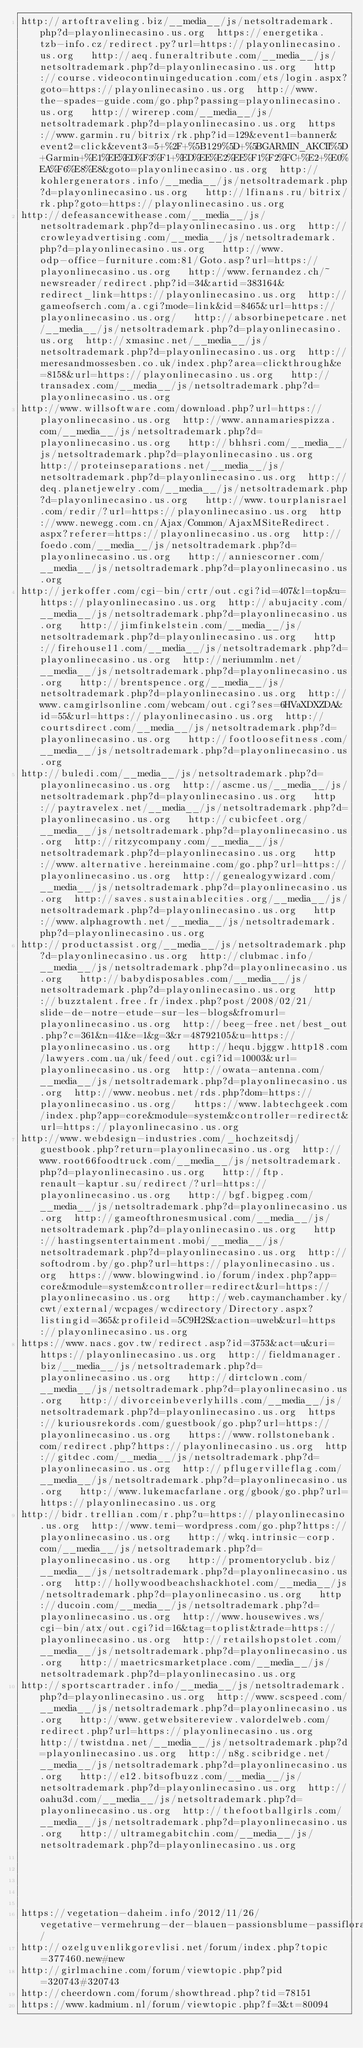<code> <loc_0><loc_0><loc_500><loc_500><_Lisp_>http://artoftraveling.biz/__media__/js/netsoltrademark.php?d=playonlinecasino.us.org  https://energetika.tzb-info.cz/redirect.py?url=https://playonlinecasino.us.org   http://aeq.funeraltribute.com/__media__/js/netsoltrademark.php?d=playonlinecasino.us.org   http://course.videocontinuingeducation.com/ets/login.aspx?goto=https://playonlinecasino.us.org  http://www.the-spades-guide.com/go.php?passing=playonlinecasino.us.org   http://wirerep.com/__media__/js/netsoltrademark.php?d=playonlinecasino.us.org  https://www.garmin.ru/bitrix/rk.php?id=129&event1=banner&event2=click&event3=5+%2F+%5B129%5D+%5BGARMIN_AKCII%5D+Garmin+%E1%EE%ED%F3%F1+%ED%EE%E2%EE%F1%F2%FC+%E2+%E0%EA%F6%E8%E8&goto=playonlinecasino.us.org  http://kohlergenerators.info/__media__/js/netsoltrademark.php?d=playonlinecasino.us.org   http://lfinans.ru/bitrix/rk.php?goto=https://playonlinecasino.us.org 
http://defeasancewithease.com/__media__/js/netsoltrademark.php?d=playonlinecasino.us.org  http://crowleyadvertising.com/__media__/js/netsoltrademark.php?d=playonlinecasino.us.org   http://www.odp-office-furniture.com:81/Goto.asp?url=https://playonlinecasino.us.org   http://www.fernandez.ch/~newsreader/redirect.php?id=34&artid=383164&redirect_link=https://playonlinecasino.us.org  http://gameofserch.com/a.cgi?mode=link&id=8465&url=https://playonlinecasino.us.org/   http://absorbinepetcare.net/__media__/js/netsoltrademark.php?d=playonlinecasino.us.org  http://xmasinc.net/__media__/js/netsoltrademark.php?d=playonlinecasino.us.org  http://meresandmossesben.co.uk/index.php?area=clickthrough&e=8158&url=https://playonlinecasino.us.org   http://transadex.com/__media__/js/netsoltrademark.php?d=playonlinecasino.us.org 
http://www.willsoftware.com/download.php?url=https://playonlinecasino.us.org  http://www.annamariespizza.com/__media__/js/netsoltrademark.php?d=playonlinecasino.us.org   http://bhhsri.com/__media__/js/netsoltrademark.php?d=playonlinecasino.us.org   http://proteinseparations.net/__media__/js/netsoltrademark.php?d=playonlinecasino.us.org  http://deq.planetjewelry.com/__media__/js/netsoltrademark.php?d=playonlinecasino.us.org   http://www.tourplanisrael.com/redir/?url=https://playonlinecasino.us.org  http://www.newegg.com.cn/Ajax/Common/AjaxMSiteRedirect.aspx?referer=https://playonlinecasino.us.org  http://foedo.com/__media__/js/netsoltrademark.php?d=playonlinecasino.us.org   http://anniescorner.com/__media__/js/netsoltrademark.php?d=playonlinecasino.us.org 
http://jerkoffer.com/cgi-bin/crtr/out.cgi?id=407&l=top&u=https://playonlinecasino.us.org  http://abujacity.com/__media__/js/netsoltrademark.php?d=playonlinecasino.us.org   http://jimfinkelstein.com/__media__/js/netsoltrademark.php?d=playonlinecasino.us.org   http://firehouse11.com/__media__/js/netsoltrademark.php?d=playonlinecasino.us.org  http://neriummlm.net/__media__/js/netsoltrademark.php?d=playonlinecasino.us.org   http://brentspence.org/__media__/js/netsoltrademark.php?d=playonlinecasino.us.org  http://www.camgirlsonline.com/webcam/out.cgi?ses=6HVaXDXZDA&id=55&url=https://playonlinecasino.us.org  http://courtsdirect.com/__media__/js/netsoltrademark.php?d=playonlinecasino.us.org   http://footloosefitness.com/__media__/js/netsoltrademark.php?d=playonlinecasino.us.org 
http://buledi.com/__media__/js/netsoltrademark.php?d=playonlinecasino.us.org  http://ascme.us/__media__/js/netsoltrademark.php?d=playonlinecasino.us.org   http://paytravelex.net/__media__/js/netsoltrademark.php?d=playonlinecasino.us.org   http://cubicfeet.org/__media__/js/netsoltrademark.php?d=playonlinecasino.us.org  http://ritzycompany.com/__media__/js/netsoltrademark.php?d=playonlinecasino.us.org   http://www.alternative.hereinmaine.com/go.php?url=https://playonlinecasino.us.org  http://genealogywizard.com/__media__/js/netsoltrademark.php?d=playonlinecasino.us.org  http://saves.sustainablecities.org/__media__/js/netsoltrademark.php?d=playonlinecasino.us.org   http://www.alphagrowth.net/__media__/js/netsoltrademark.php?d=playonlinecasino.us.org 
http://productassist.org/__media__/js/netsoltrademark.php?d=playonlinecasino.us.org  http://clubmac.info/__media__/js/netsoltrademark.php?d=playonlinecasino.us.org   http://babydisposables.com/__media__/js/netsoltrademark.php?d=playonlinecasino.us.org   http://buzztalent.free.fr/index.php?post/2008/02/21/slide-de-notre-etude-sur-les-blogs&fromurl=playonlinecasino.us.org  http://beeg-free.net/best_out.php?c=361&n=41&e=1&g=3&r=48792105&u=https://playonlinecasino.us.org   http://hequ.bjggw.http18.com/lawyers.com.ua/uk/feed/out.cgi?id=10003&url=playonlinecasino.us.org  http://owata-antenna.com/__media__/js/netsoltrademark.php?d=playonlinecasino.us.org  http://www.neobus.net/rds.php?dom=https://playonlinecasino.us.org/   https://www.labtechgeek.com/index.php?app=core&module=system&controller=redirect&url=https://playonlinecasino.us.org 
http://www.webdesign-industries.com/_hochzeitsdj/guestbook.php?return=playonlinecasino.us.org  http://www.root66foodtruck.com/__media__/js/netsoltrademark.php?d=playonlinecasino.us.org   http://ftp.renault-kaptur.su/redirect/?url=https://playonlinecasino.us.org   http://bgf.bigpeg.com/__media__/js/netsoltrademark.php?d=playonlinecasino.us.org  http://gameofthronesmusical.com/__media__/js/netsoltrademark.php?d=playonlinecasino.us.org   http://hastingsentertainment.mobi/__media__/js/netsoltrademark.php?d=playonlinecasino.us.org  http://softodrom.by/go.php?url=https://playonlinecasino.us.org  https://www.blowingwind.io/forum/index.php?app=core&module=system&controller=redirect&url=https://playonlinecasino.us.org   http://web.caymanchamber.ky/cwt/external/wcpages/wcdirectory/Directory.aspx?listingid=365&profileid=5C9H2S&action=uweb&url=https://playonlinecasino.us.org 
https://www.nacs.gov.tw/redirect.asp?id=3753&act=u&uri=https://playonlinecasino.us.org  http://fieldmanager.biz/__media__/js/netsoltrademark.php?d=playonlinecasino.us.org   http://dirtclown.com/__media__/js/netsoltrademark.php?d=playonlinecasino.us.org   http://divorceinbeverlyhills.com/__media__/js/netsoltrademark.php?d=playonlinecasino.us.org  https://kuriousrekords.com/guestbook/go.php?url=https://playonlinecasino.us.org   https://www.rollstonebank.com/redirect.php?https://playonlinecasino.us.org  http://gitdec.com/__media__/js/netsoltrademark.php?d=playonlinecasino.us.org  http://pflugervilleflag.com/__media__/js/netsoltrademark.php?d=playonlinecasino.us.org   http://www.lukemacfarlane.org/gbook/go.php?url=https://playonlinecasino.us.org 
http://bidr.trellian.com/r.php?u=https://playonlinecasino.us.org  http://www.temi-wordpress.com/go.php?https://playonlinecasino.us.org   http://wkq.intrinsic-corp.com/__media__/js/netsoltrademark.php?d=playonlinecasino.us.org   http://promentoryclub.biz/__media__/js/netsoltrademark.php?d=playonlinecasino.us.org  http://hollywoodbeachshackhotel.com/__media__/js/netsoltrademark.php?d=playonlinecasino.us.org   http://ducoin.com/__media__/js/netsoltrademark.php?d=playonlinecasino.us.org  http://www.housewives.ws/cgi-bin/atx/out.cgi?id=16&tag=toplist&trade=https://playonlinecasino.us.org  http://retailshopstolet.com/__media__/js/netsoltrademark.php?d=playonlinecasino.us.org   http://maetricsmarketplace.com/__media__/js/netsoltrademark.php?d=playonlinecasino.us.org 
http://sportscartrader.info/__media__/js/netsoltrademark.php?d=playonlinecasino.us.org  http://www.scspeed.com/__media__/js/netsoltrademark.php?d=playonlinecasino.us.org   http://www.getwebsitereview.valordelweb.com/redirect.php?url=https://playonlinecasino.us.org   http://twistdna.net/__media__/js/netsoltrademark.php?d=playonlinecasino.us.org  http://n8g.scibridge.net/__media__/js/netsoltrademark.php?d=playonlinecasino.us.org   http://e12.bitsofbuzz.com/__media__/js/netsoltrademark.php?d=playonlinecasino.us.org  http://oahu3d.com/__media__/js/netsoltrademark.php?d=playonlinecasino.us.org  http://thefootballgirls.com/__media__/js/netsoltrademark.php?d=playonlinecasino.us.org   http://ultramegabitchin.com/__media__/js/netsoltrademark.php?d=playonlinecasino.us.org 
 
 
 
 
 
https://vegetation-daheim.info/2012/11/26/vegetative-vermehrung-der-blauen-passionsblume-passiflora-caerulea/
http://ozelguvenlikgorevlisi.net/forum/index.php?topic=377460.new#new
http://girlmachine.com/forum/viewtopic.php?pid=320743#320743
http://cheerdown.com/forum/showthread.php?tid=78151
https://www.kadmium.nl/forum/viewtopic.php?f=3&t=80094
</code> 